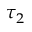Convert formula to latex. <formula><loc_0><loc_0><loc_500><loc_500>\tau _ { 2 }</formula> 